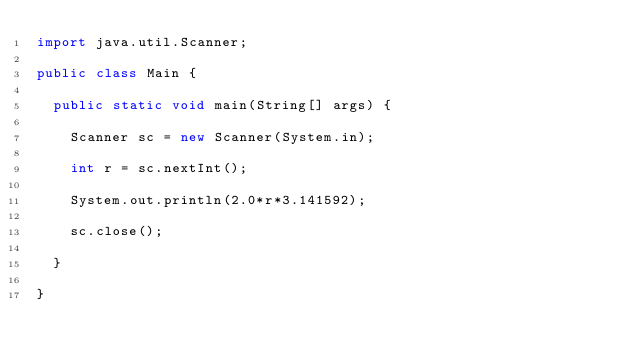<code> <loc_0><loc_0><loc_500><loc_500><_Java_>import java.util.Scanner;

public class Main {

	public static void main(String[] args) {

		Scanner sc = new Scanner(System.in);

		int r = sc.nextInt();

		System.out.println(2.0*r*3.141592);

		sc.close();

	}

}
</code> 